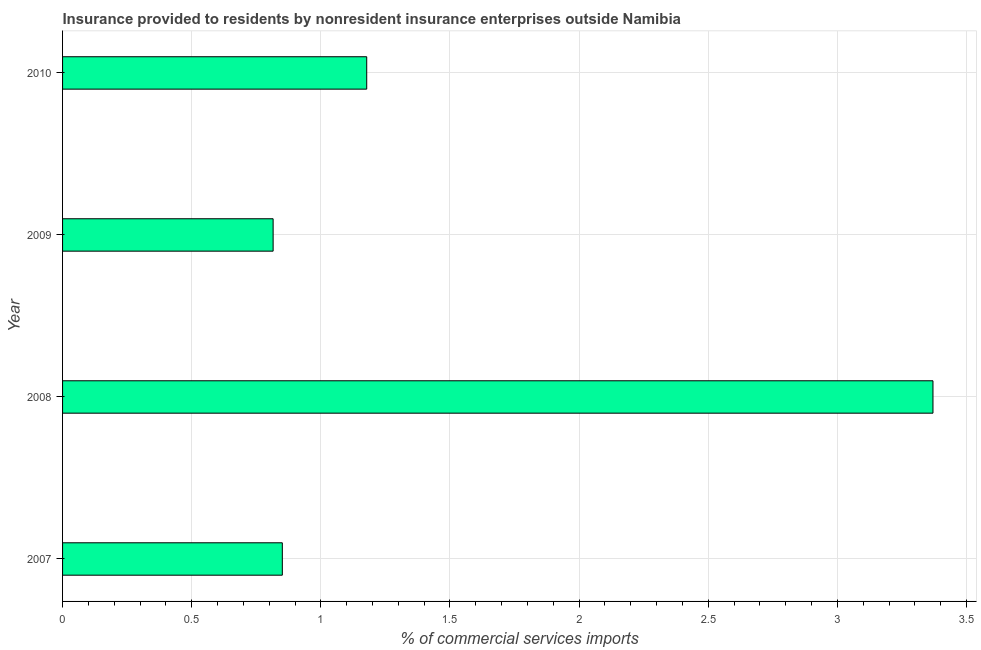Does the graph contain any zero values?
Provide a succinct answer. No. What is the title of the graph?
Offer a very short reply. Insurance provided to residents by nonresident insurance enterprises outside Namibia. What is the label or title of the X-axis?
Give a very brief answer. % of commercial services imports. What is the insurance provided by non-residents in 2008?
Your answer should be compact. 3.37. Across all years, what is the maximum insurance provided by non-residents?
Make the answer very short. 3.37. Across all years, what is the minimum insurance provided by non-residents?
Make the answer very short. 0.82. In which year was the insurance provided by non-residents minimum?
Provide a short and direct response. 2009. What is the sum of the insurance provided by non-residents?
Provide a short and direct response. 6.21. What is the difference between the insurance provided by non-residents in 2007 and 2009?
Your answer should be very brief. 0.04. What is the average insurance provided by non-residents per year?
Offer a terse response. 1.55. What is the median insurance provided by non-residents?
Provide a succinct answer. 1.01. In how many years, is the insurance provided by non-residents greater than 0.8 %?
Keep it short and to the point. 4. Do a majority of the years between 2007 and 2010 (inclusive) have insurance provided by non-residents greater than 2.6 %?
Your answer should be compact. No. What is the ratio of the insurance provided by non-residents in 2009 to that in 2010?
Make the answer very short. 0.69. Is the insurance provided by non-residents in 2009 less than that in 2010?
Your answer should be very brief. Yes. What is the difference between the highest and the second highest insurance provided by non-residents?
Give a very brief answer. 2.19. What is the difference between the highest and the lowest insurance provided by non-residents?
Keep it short and to the point. 2.55. How many bars are there?
Provide a succinct answer. 4. How many years are there in the graph?
Keep it short and to the point. 4. What is the % of commercial services imports in 2007?
Offer a very short reply. 0.85. What is the % of commercial services imports in 2008?
Provide a succinct answer. 3.37. What is the % of commercial services imports of 2009?
Offer a terse response. 0.82. What is the % of commercial services imports in 2010?
Provide a succinct answer. 1.18. What is the difference between the % of commercial services imports in 2007 and 2008?
Keep it short and to the point. -2.52. What is the difference between the % of commercial services imports in 2007 and 2009?
Keep it short and to the point. 0.04. What is the difference between the % of commercial services imports in 2007 and 2010?
Give a very brief answer. -0.33. What is the difference between the % of commercial services imports in 2008 and 2009?
Offer a very short reply. 2.55. What is the difference between the % of commercial services imports in 2008 and 2010?
Make the answer very short. 2.19. What is the difference between the % of commercial services imports in 2009 and 2010?
Offer a very short reply. -0.36. What is the ratio of the % of commercial services imports in 2007 to that in 2008?
Offer a terse response. 0.25. What is the ratio of the % of commercial services imports in 2007 to that in 2009?
Your answer should be very brief. 1.04. What is the ratio of the % of commercial services imports in 2007 to that in 2010?
Provide a short and direct response. 0.72. What is the ratio of the % of commercial services imports in 2008 to that in 2009?
Your answer should be very brief. 4.13. What is the ratio of the % of commercial services imports in 2008 to that in 2010?
Offer a terse response. 2.86. What is the ratio of the % of commercial services imports in 2009 to that in 2010?
Your response must be concise. 0.69. 